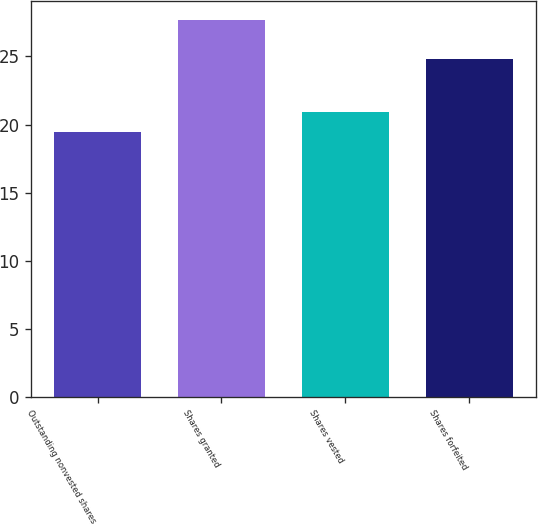<chart> <loc_0><loc_0><loc_500><loc_500><bar_chart><fcel>Outstanding nonvested shares<fcel>Shares granted<fcel>Shares vested<fcel>Shares forfeited<nl><fcel>19.46<fcel>27.64<fcel>20.94<fcel>24.81<nl></chart> 